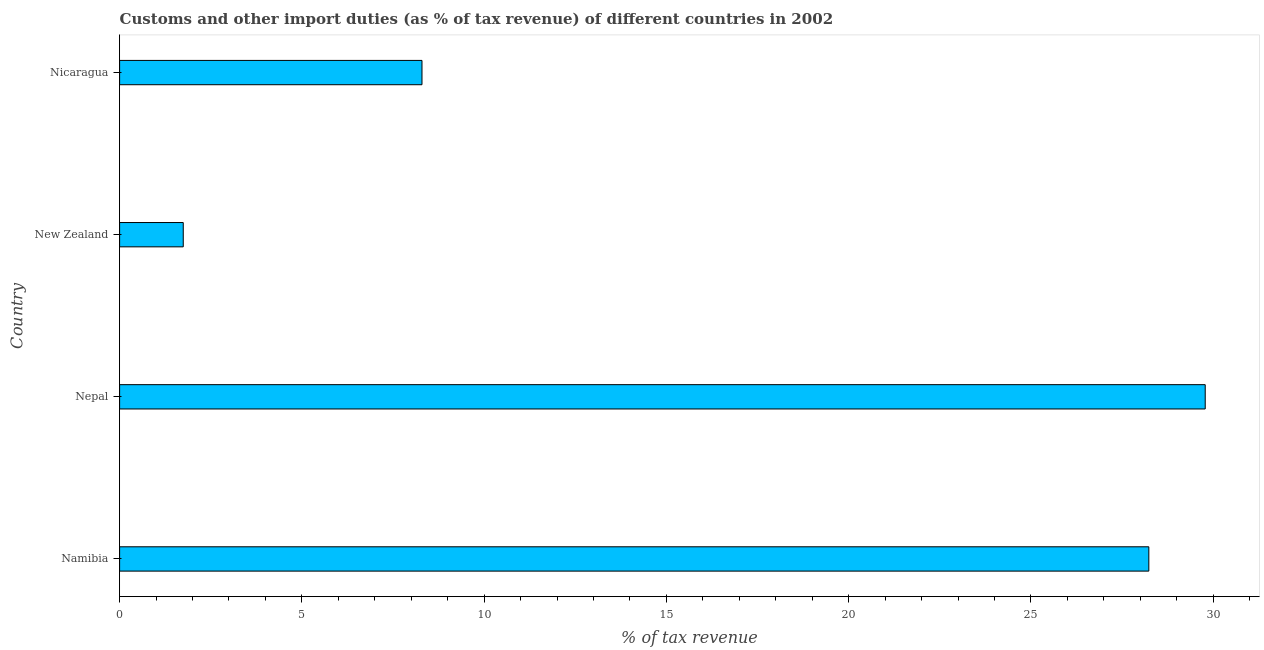Does the graph contain any zero values?
Give a very brief answer. No. What is the title of the graph?
Your response must be concise. Customs and other import duties (as % of tax revenue) of different countries in 2002. What is the label or title of the X-axis?
Your answer should be very brief. % of tax revenue. What is the customs and other import duties in Namibia?
Give a very brief answer. 28.23. Across all countries, what is the maximum customs and other import duties?
Make the answer very short. 29.78. Across all countries, what is the minimum customs and other import duties?
Ensure brevity in your answer.  1.75. In which country was the customs and other import duties maximum?
Make the answer very short. Nepal. In which country was the customs and other import duties minimum?
Your answer should be very brief. New Zealand. What is the sum of the customs and other import duties?
Offer a very short reply. 68.06. What is the difference between the customs and other import duties in New Zealand and Nicaragua?
Give a very brief answer. -6.55. What is the average customs and other import duties per country?
Ensure brevity in your answer.  17.01. What is the median customs and other import duties?
Your answer should be very brief. 18.26. In how many countries, is the customs and other import duties greater than 17 %?
Ensure brevity in your answer.  2. What is the ratio of the customs and other import duties in Nepal to that in Nicaragua?
Offer a very short reply. 3.59. Is the difference between the customs and other import duties in Namibia and Nicaragua greater than the difference between any two countries?
Your answer should be compact. No. What is the difference between the highest and the second highest customs and other import duties?
Give a very brief answer. 1.55. Is the sum of the customs and other import duties in Namibia and Nepal greater than the maximum customs and other import duties across all countries?
Provide a short and direct response. Yes. What is the difference between the highest and the lowest customs and other import duties?
Your answer should be compact. 28.03. How many bars are there?
Provide a short and direct response. 4. Are all the bars in the graph horizontal?
Your response must be concise. Yes. What is the difference between two consecutive major ticks on the X-axis?
Your answer should be compact. 5. What is the % of tax revenue in Namibia?
Keep it short and to the point. 28.23. What is the % of tax revenue of Nepal?
Provide a short and direct response. 29.78. What is the % of tax revenue of New Zealand?
Give a very brief answer. 1.75. What is the % of tax revenue in Nicaragua?
Your response must be concise. 8.29. What is the difference between the % of tax revenue in Namibia and Nepal?
Offer a very short reply. -1.55. What is the difference between the % of tax revenue in Namibia and New Zealand?
Your answer should be very brief. 26.49. What is the difference between the % of tax revenue in Namibia and Nicaragua?
Keep it short and to the point. 19.94. What is the difference between the % of tax revenue in Nepal and New Zealand?
Ensure brevity in your answer.  28.03. What is the difference between the % of tax revenue in Nepal and Nicaragua?
Your answer should be very brief. 21.49. What is the difference between the % of tax revenue in New Zealand and Nicaragua?
Your response must be concise. -6.55. What is the ratio of the % of tax revenue in Namibia to that in Nepal?
Give a very brief answer. 0.95. What is the ratio of the % of tax revenue in Namibia to that in New Zealand?
Ensure brevity in your answer.  16.17. What is the ratio of the % of tax revenue in Namibia to that in Nicaragua?
Your answer should be very brief. 3.4. What is the ratio of the % of tax revenue in Nepal to that in New Zealand?
Offer a terse response. 17.06. What is the ratio of the % of tax revenue in Nepal to that in Nicaragua?
Offer a very short reply. 3.59. What is the ratio of the % of tax revenue in New Zealand to that in Nicaragua?
Give a very brief answer. 0.21. 